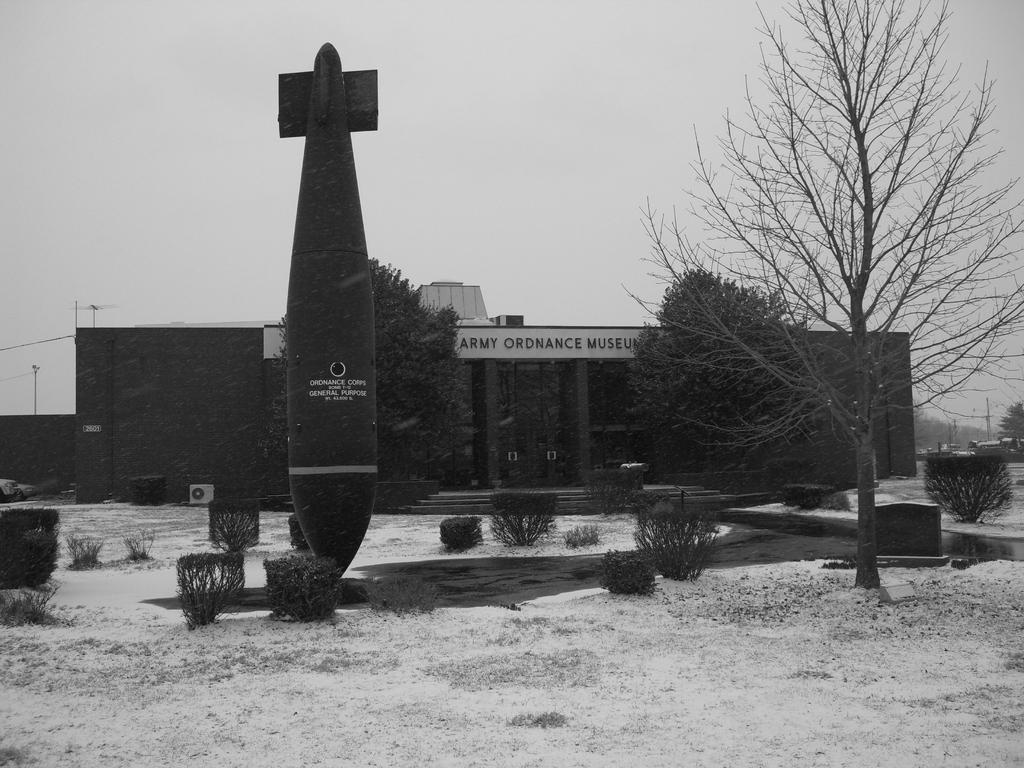What is the main subject in the picture? There is an object in the picture. What is located near the object? There are plants beside the object. Can you describe the building in the picture? There is a building with writing on it in the picture. What type of vegetation is visible in the right corner of the image? There are trees in the right corner of the image. What type of button can be seen on the potato in the image? There is no button or potato present in the image. 